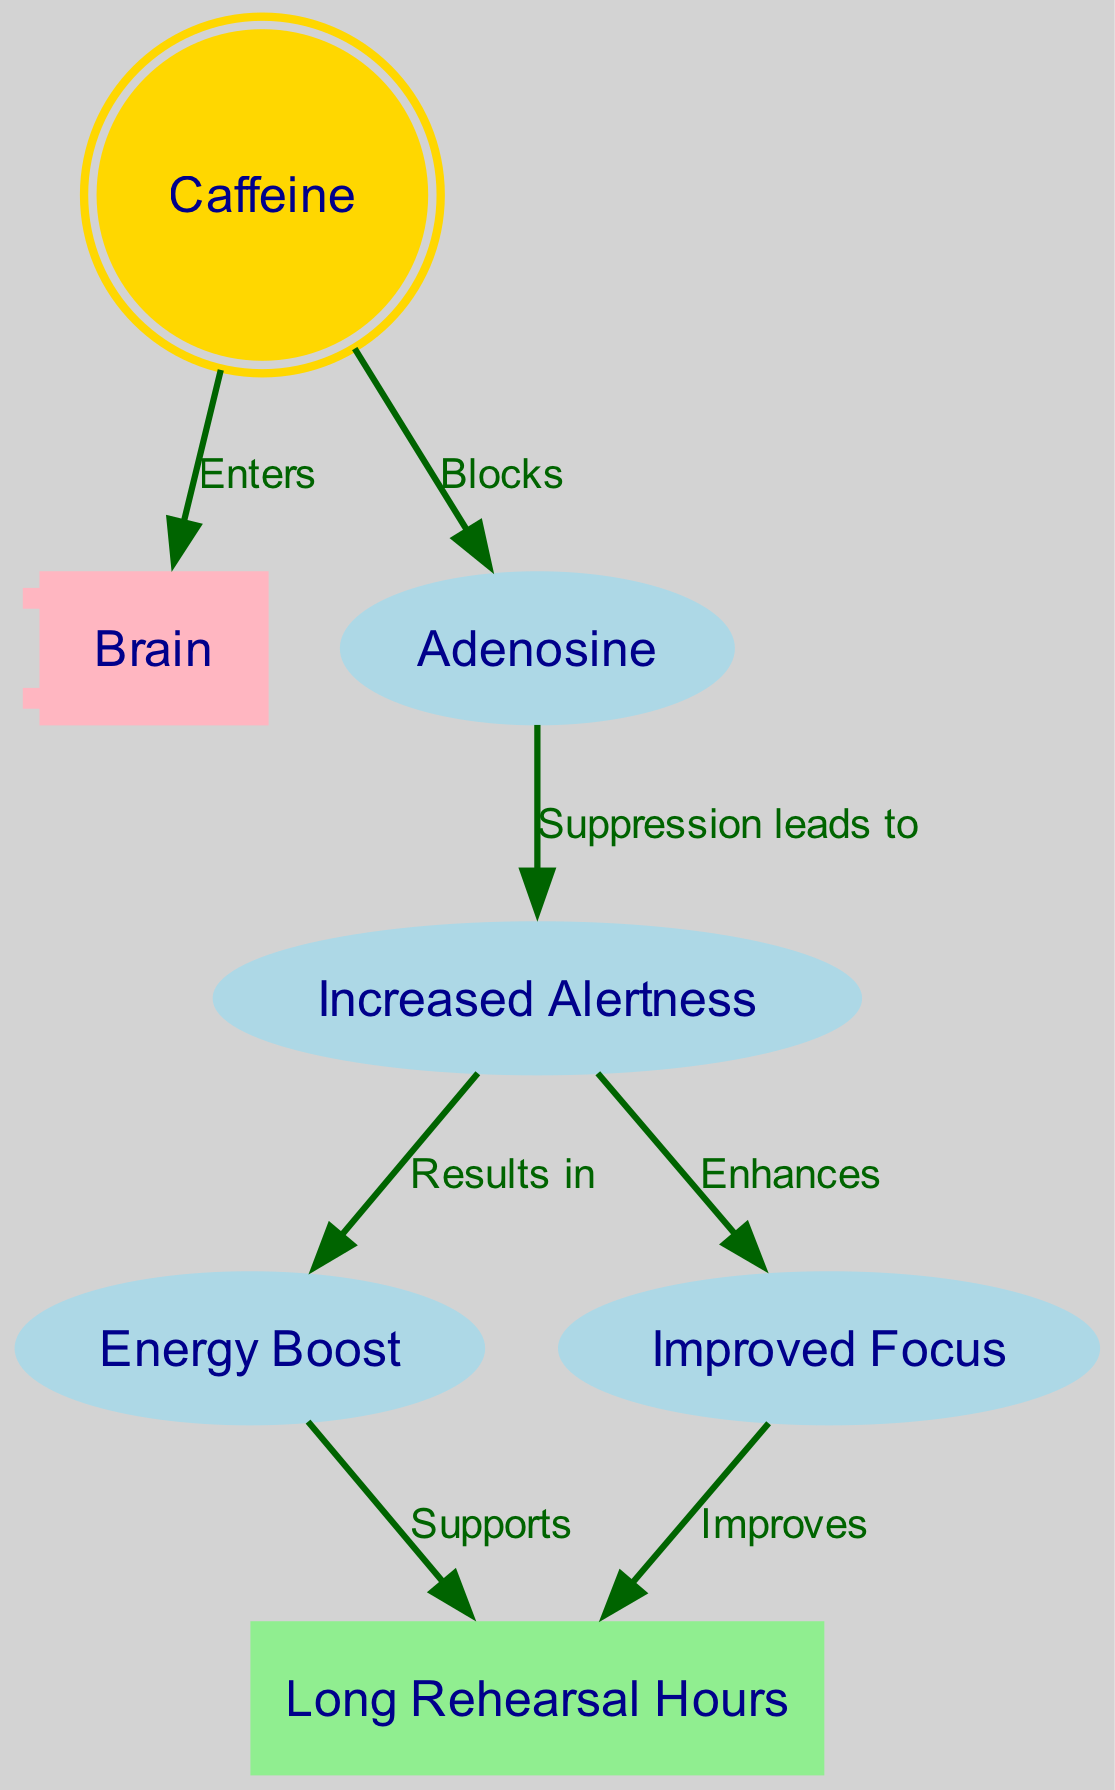What is the total number of nodes in the diagram? The diagram includes nodes for Caffeine, Brain, Adenosine, Increased Alertness, Energy Boost, Improved Focus, and Long Rehearsal Hours. Counting these nodes gives a total of 7.
Answer: 7 What effect does caffeine have on adenosine? In the diagram, caffeine is shown to block adenosine. Therefore, it prevents adenosine from having its usual effects.
Answer: Blocks What does increased alertness result in? Following the flow in the diagram, increased alertness leads to an energy boost and improved focus. However, since the question asks for a specific result, the answer is that it results in energy.
Answer: Energy Boost Which node supports long rehearsal hours? The diagram indicates two nodes (Energy and Improved Focus) that support long rehearsal hours. However, if asked for just one specific node, we can refer to energy as it directly supports energy required for rehearsals.
Answer: Energy Boost What role does adenosine play in the diagram concerning alertness? Adenosine, when not blocked by caffeine, has a suppressing effect on alertness. This means that the presence of adenosine would normally reduce alertness levels.
Answer: Suppression How does energy influence rehearsal hours? According to the edges in the diagram, there is a direct connection from energy to rehearsal, indicating that energy contributes to the ability to manage long rehearsal hours.
Answer: Supports 